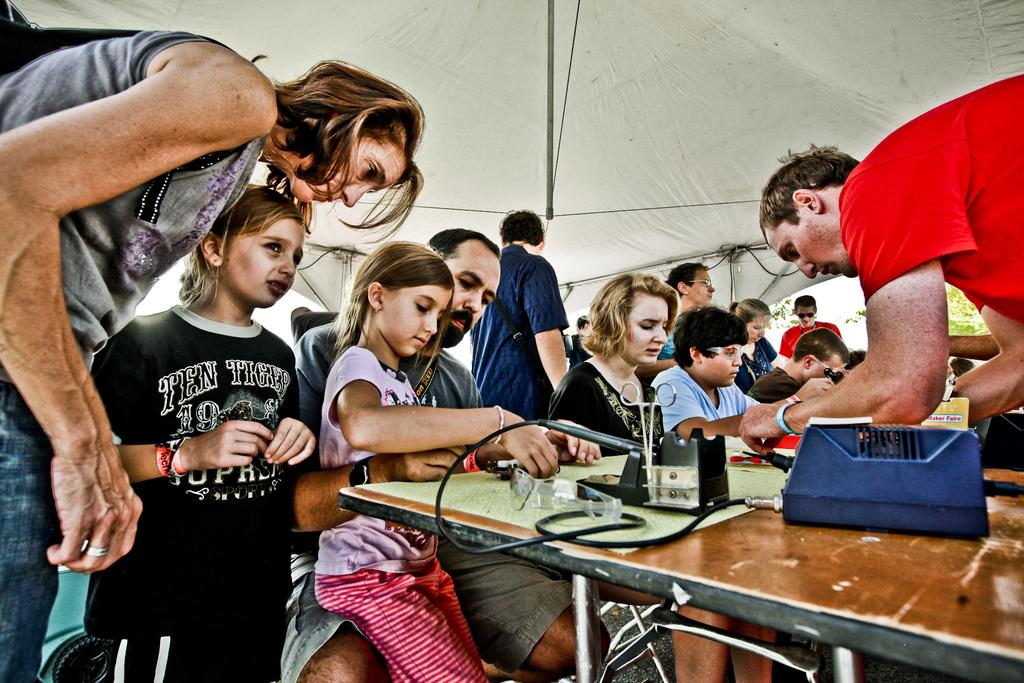Who or what is in the image? There are people in the image. What is the main object in the image? There is a table in the image. What items can be found on the table? Scissors, glasses, and other objects are present on the table. What type of structure is visible in the image? There is a white tent in the image. What type of fruit is being marked by the person's nose in the image? There is no fruit or person's nose present in the image. 